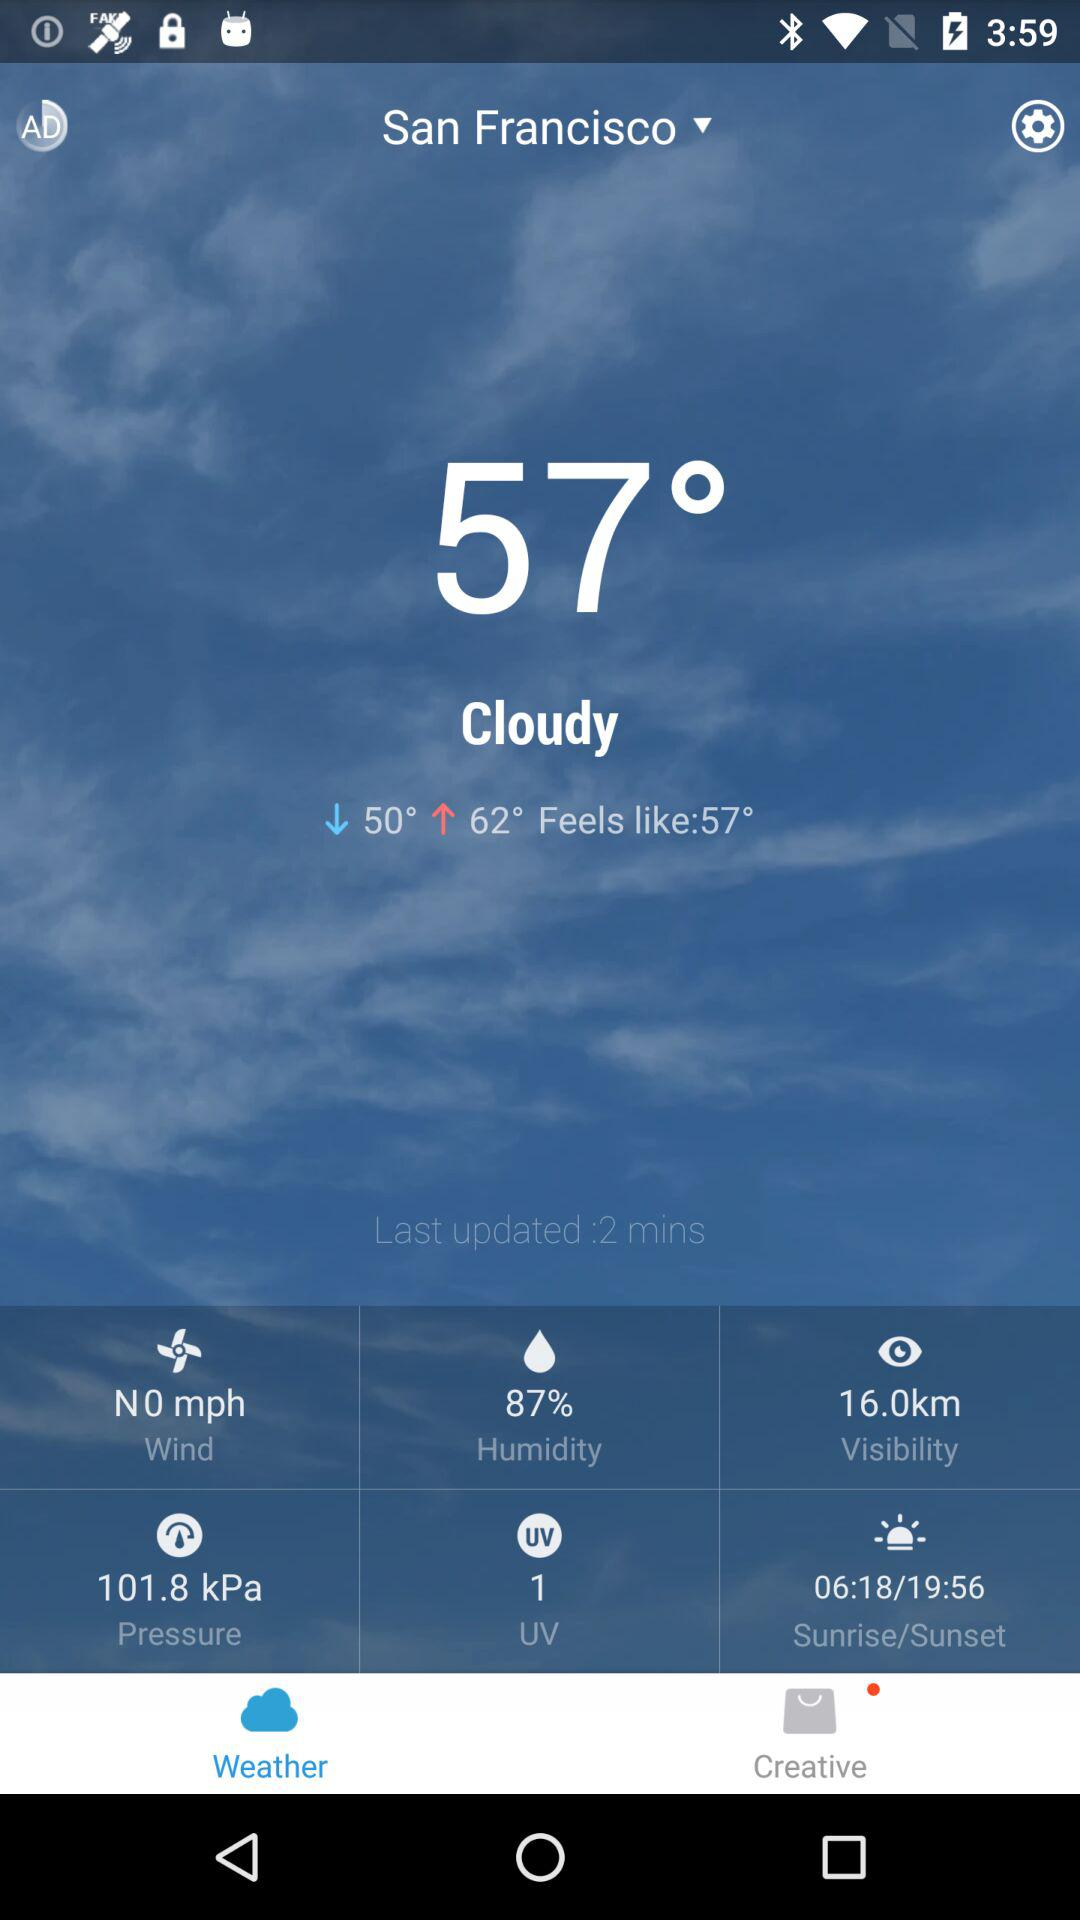What is the pressure currently?
Answer the question using a single word or phrase. 101.8 kPa 